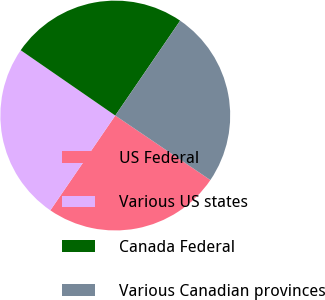Convert chart. <chart><loc_0><loc_0><loc_500><loc_500><pie_chart><fcel>US Federal<fcel>Various US states<fcel>Canada Federal<fcel>Various Canadian provinces<nl><fcel>25.07%<fcel>25.06%<fcel>24.93%<fcel>24.94%<nl></chart> 